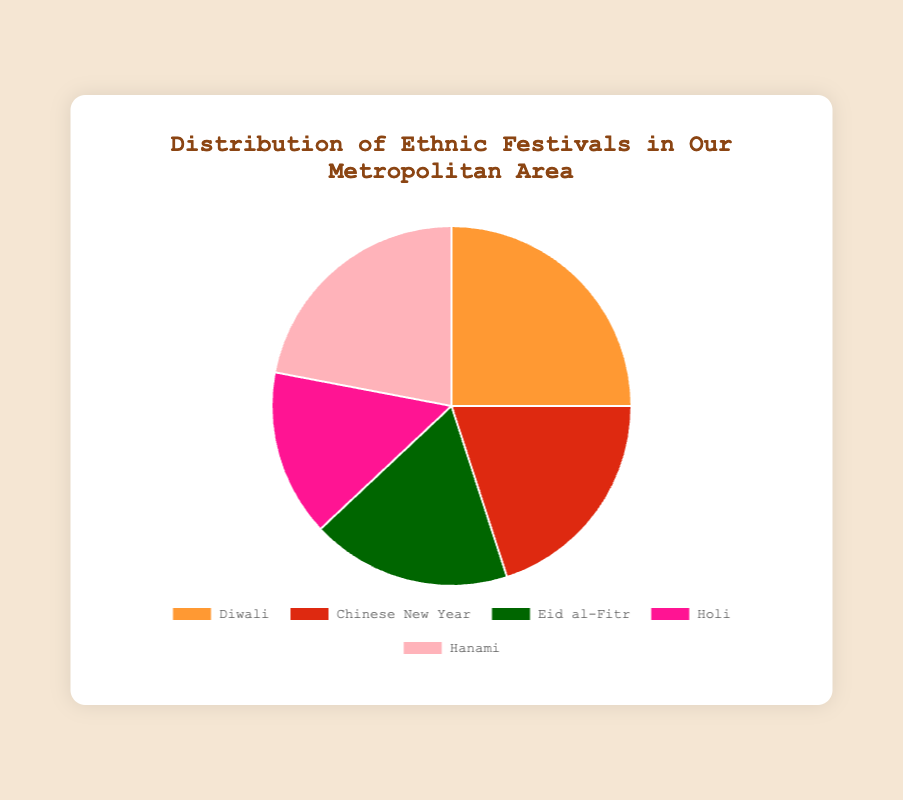Which festival has the highest percentage of celebration? Diwali has the highest percentage of celebration in the pie chart at 25%. This is directly observed from the labeled data points in the chart.
Answer: Diwali Which festival is celebrated more, Hanami or Holi? The pie chart shows that Hanami is celebrated by 22% of the population, while Holi is celebrated by 15%. Comparing these two values, Hanami has a higher percentage.
Answer: Hanami What is the combined percentage of Diwali and Eid al-Fitr celebrations? To find the combined percentage, add the percentages of Diwali and Eid al-Fitr: 25% (Diwali) + 18% (Eid al-Fitr) = 43%.
Answer: 43% Is Chinese New Year celebrated more than Eid al-Fitr? The pie chart indicates that Chinese New Year is celebrated by 20% of the population, whereas Eid al-Fitr is celebrated by 18%. Therefore, Chinese New Year has a slightly higher percentage.
Answer: Yes What is the difference in percentage between the most and least celebrated festivals? The most celebrated festival is Diwali at 25%, and the least celebrated is Holi at 15%. The difference is calculated as follows: 25% - 15% = 10%.
Answer: 10% Which segment is represented with the color green in the chart? The color green in the pie chart represents the Eid al-Fitr segment.
Answer: Eid al-Fitr How many festivals account for at least 20% of the celebrations individually? According to the pie chart, Diwali (25%), Hanami (22%), and Chinese New Year (20%) each account for at least 20% of the celebrations. So, there are three festivals meeting this criterion.
Answer: 3 If a new festival with a 10% share is added to the pie chart, what would be the combined percentage of the newly added festival and Holi? Adding a new festival with a 10% share to the current percentage of Holi (15%): 10% + 15% = 25%.
Answer: 25% Which festival is represented by the second largest segment in the pie chart? The second largest segment in the pie chart is Hanami, which is celebrated by 22% of the population.
Answer: Hanami 